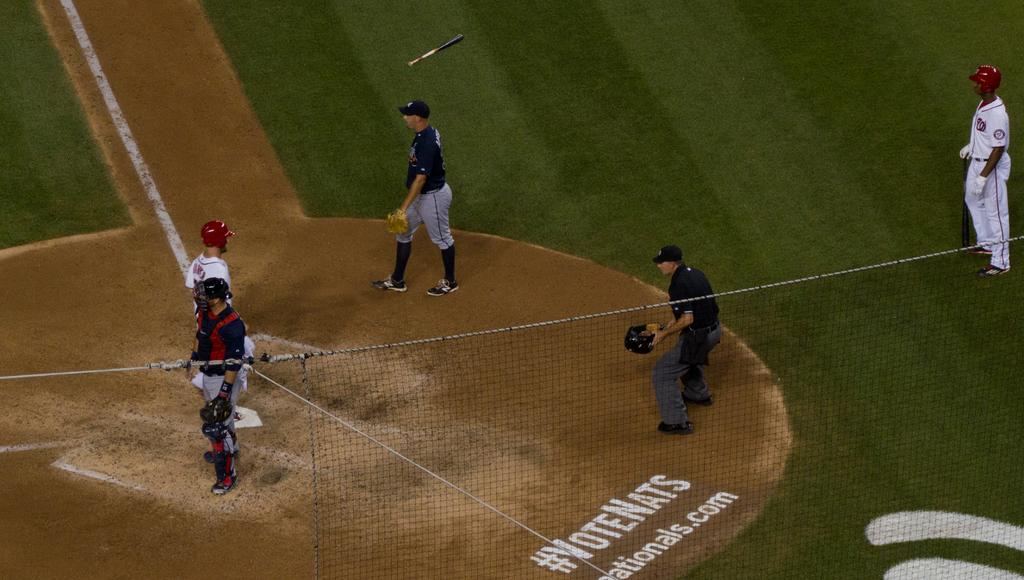<image>
Give a short and clear explanation of the subsequent image. People playing baseball on a field that says "VoteNats". 